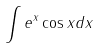Convert formula to latex. <formula><loc_0><loc_0><loc_500><loc_500>\int e ^ { x } \cos x d x</formula> 